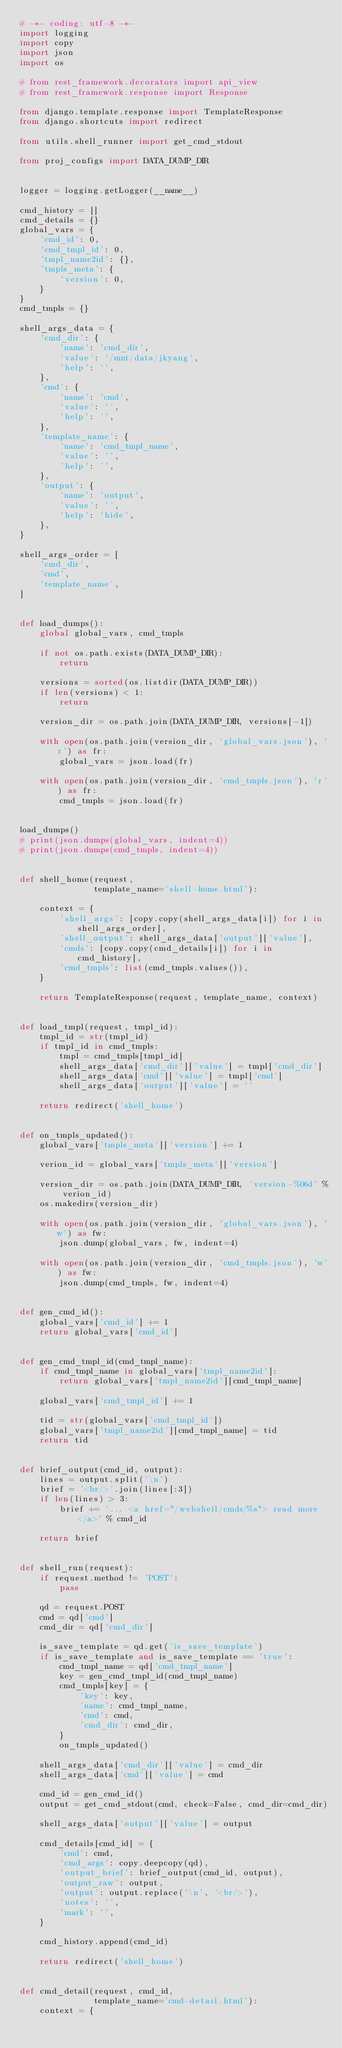<code> <loc_0><loc_0><loc_500><loc_500><_Python_># -*- coding: utf-8 -*-
import logging
import copy
import json
import os

# from rest_framework.decorators import api_view
# from rest_framework.response import Response

from django.template.response import TemplateResponse
from django.shortcuts import redirect

from utils.shell_runner import get_cmd_stdout

from proj_configs import DATA_DUMP_DIR


logger = logging.getLogger(__name__)

cmd_history = []
cmd_details = {}
global_vars = {
    'cmd_id': 0,
    'cmd_tmpl_id': 0,
    'tmpl_name2id': {},
    'tmpls_meta': {
        'version': 0,
    }
}
cmd_tmpls = {}

shell_args_data = {
    'cmd_dir': {
        'name': 'cmd_dir',
        'value': '/mnt/data/jkyang',
        'help': '',
    },
    'cmd': {
        'name': 'cmd',
        'value': '',
        'help': '',
    },
    'template_name': {
        'name': 'cmd_tmpl_name',
        'value': '',
        'help': '',
    },
    'output': {
        'name': 'output',
        'value': '',
        'help': 'hide',
    },
}

shell_args_order = [
    'cmd_dir',
    'cmd',
    'template_name',
]


def load_dumps():
    global global_vars, cmd_tmpls

    if not os.path.exists(DATA_DUMP_DIR):
        return

    versions = sorted(os.listdir(DATA_DUMP_DIR))
    if len(versions) < 1:
        return

    version_dir = os.path.join(DATA_DUMP_DIR, versions[-1])

    with open(os.path.join(version_dir, 'global_vars.json'), 'r') as fr:
        global_vars = json.load(fr)

    with open(os.path.join(version_dir, 'cmd_tmpls.json'), 'r') as fr:
        cmd_tmpls = json.load(fr)


load_dumps()
# print(json.dumps(global_vars, indent=4))
# print(json.dumps(cmd_tmpls, indent=4))


def shell_home(request,
               template_name='shell-home.html'):

    context = {
        'shell_args': [copy.copy(shell_args_data[i]) for i in shell_args_order],
        'shell_output': shell_args_data['output']['value'],
        'cmds': [copy.copy(cmd_details[i]) for i in cmd_history],
        'cmd_tmpls': list(cmd_tmpls.values()),
    }

    return TemplateResponse(request, template_name, context)


def load_tmpl(request, tmpl_id):
    tmpl_id = str(tmpl_id)
    if tmpl_id in cmd_tmpls:
        tmpl = cmd_tmpls[tmpl_id]
        shell_args_data['cmd_dir']['value'] = tmpl['cmd_dir']
        shell_args_data['cmd']['value'] = tmpl['cmd']
        shell_args_data['output']['value'] = ''

    return redirect('shell_home')


def on_tmpls_updated():
    global_vars['tmpls_meta']['version'] += 1

    verion_id = global_vars['tmpls_meta']['version']

    version_dir = os.path.join(DATA_DUMP_DIR, 'version-%06d' % verion_id)
    os.makedirs(version_dir)

    with open(os.path.join(version_dir, 'global_vars.json'), 'w') as fw:
        json.dump(global_vars, fw, indent=4)

    with open(os.path.join(version_dir, 'cmd_tmpls.json'), 'w') as fw:
        json.dump(cmd_tmpls, fw, indent=4)


def gen_cmd_id():
    global_vars['cmd_id'] += 1
    return global_vars['cmd_id']


def gen_cmd_tmpl_id(cmd_tmpl_name):
    if cmd_tmpl_name in global_vars['tmpl_name2id']:
        return global_vars['tmpl_name2id'][cmd_tmpl_name]

    global_vars['cmd_tmpl_id'] += 1

    tid = str(global_vars['cmd_tmpl_id'])
    global_vars['tmpl_name2id'][cmd_tmpl_name] = tid
    return tid


def brief_output(cmd_id, output):
    lines = output.split('\n')
    brief = '<br/>'.join(lines[:3])
    if len(lines) > 3:
        brief += '... <a href="/webshell/cmds/%s"> read more </a>' % cmd_id

    return brief


def shell_run(request):
    if request.method != 'POST':
        pass

    qd = request.POST
    cmd = qd['cmd']
    cmd_dir = qd['cmd_dir']

    is_save_template = qd.get('is_save_template')
    if is_save_template and is_save_template == 'true':
        cmd_tmpl_name = qd['cmd_tmpl_name']
        key = gen_cmd_tmpl_id(cmd_tmpl_name)
        cmd_tmpls[key] = {
            'key': key,
            'name': cmd_tmpl_name,
            'cmd': cmd,
            'cmd_dir': cmd_dir,
        }
        on_tmpls_updated()

    shell_args_data['cmd_dir']['value'] = cmd_dir
    shell_args_data['cmd']['value'] = cmd

    cmd_id = gen_cmd_id()
    output = get_cmd_stdout(cmd, check=False, cmd_dir=cmd_dir)

    shell_args_data['output']['value'] = output

    cmd_details[cmd_id] = {
        'cmd': cmd,
        'cmd_args': copy.deepcopy(qd),
        'output_brief': brief_output(cmd_id, output),
        'output_raw': output,
        'output': output.replace('\n', '<br/>'),
        'notes': '',
        'mark': '',
    }

    cmd_history.append(cmd_id)

    return redirect('shell_home')


def cmd_detail(request, cmd_id,
               template_name='cmd-detail.html'):
    context = {</code> 